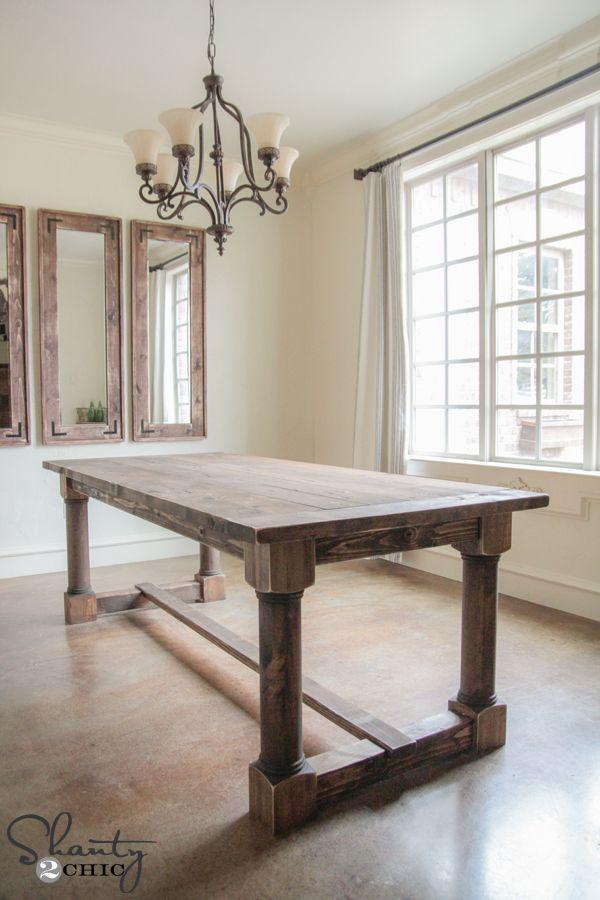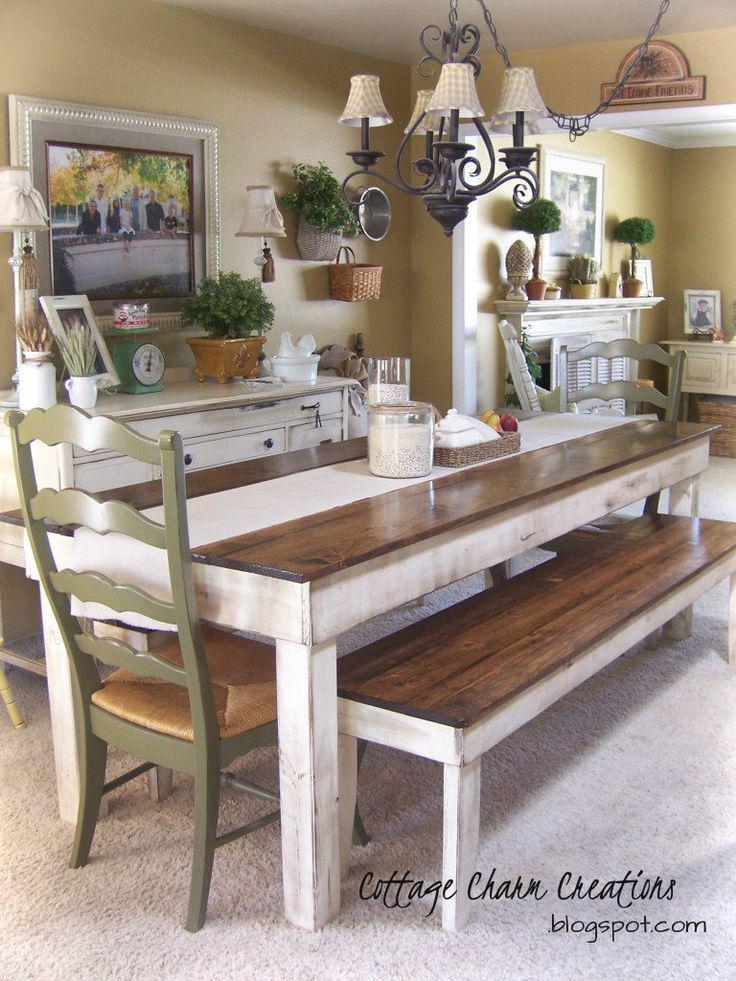The first image is the image on the left, the second image is the image on the right. For the images shown, is this caption "A plant is sitting on the table in the image on the left." true? Answer yes or no. No. 